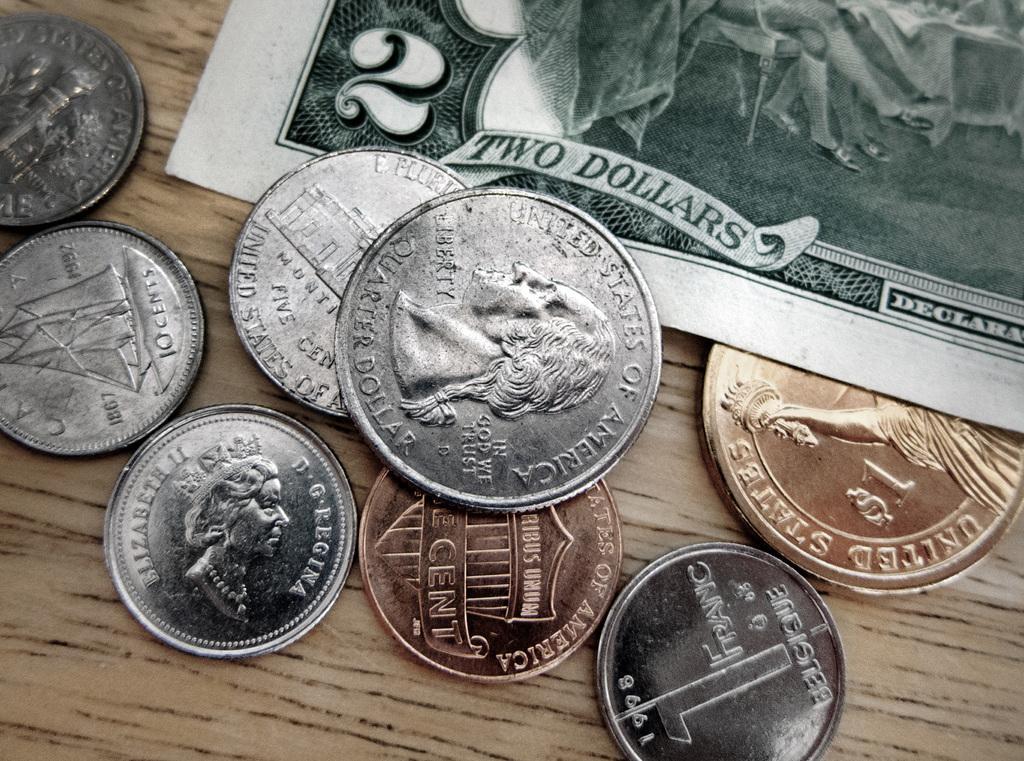Please provide a concise description of this image. In this image there are coins and a currency note on the wooden board. 